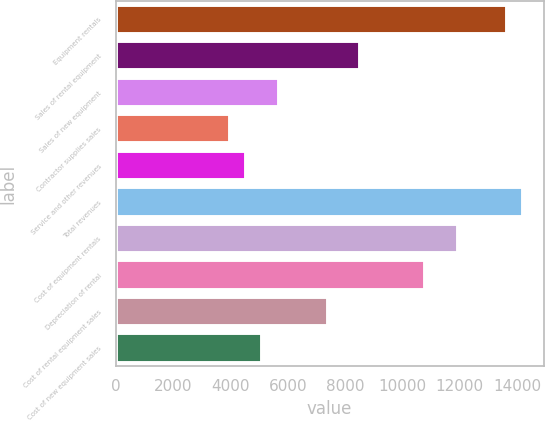<chart> <loc_0><loc_0><loc_500><loc_500><bar_chart><fcel>Equipment rentals<fcel>Sales of rental equipment<fcel>Sales of new equipment<fcel>Contractor supplies sales<fcel>Service and other revenues<fcel>Total revenues<fcel>Cost of equipment rentals<fcel>Depreciation of rental<fcel>Cost of rental equipment sales<fcel>Cost of new equipment sales<nl><fcel>13642.6<fcel>8527<fcel>5685<fcel>3979.8<fcel>4548.2<fcel>14211<fcel>11937.4<fcel>10800.6<fcel>7390.2<fcel>5116.6<nl></chart> 